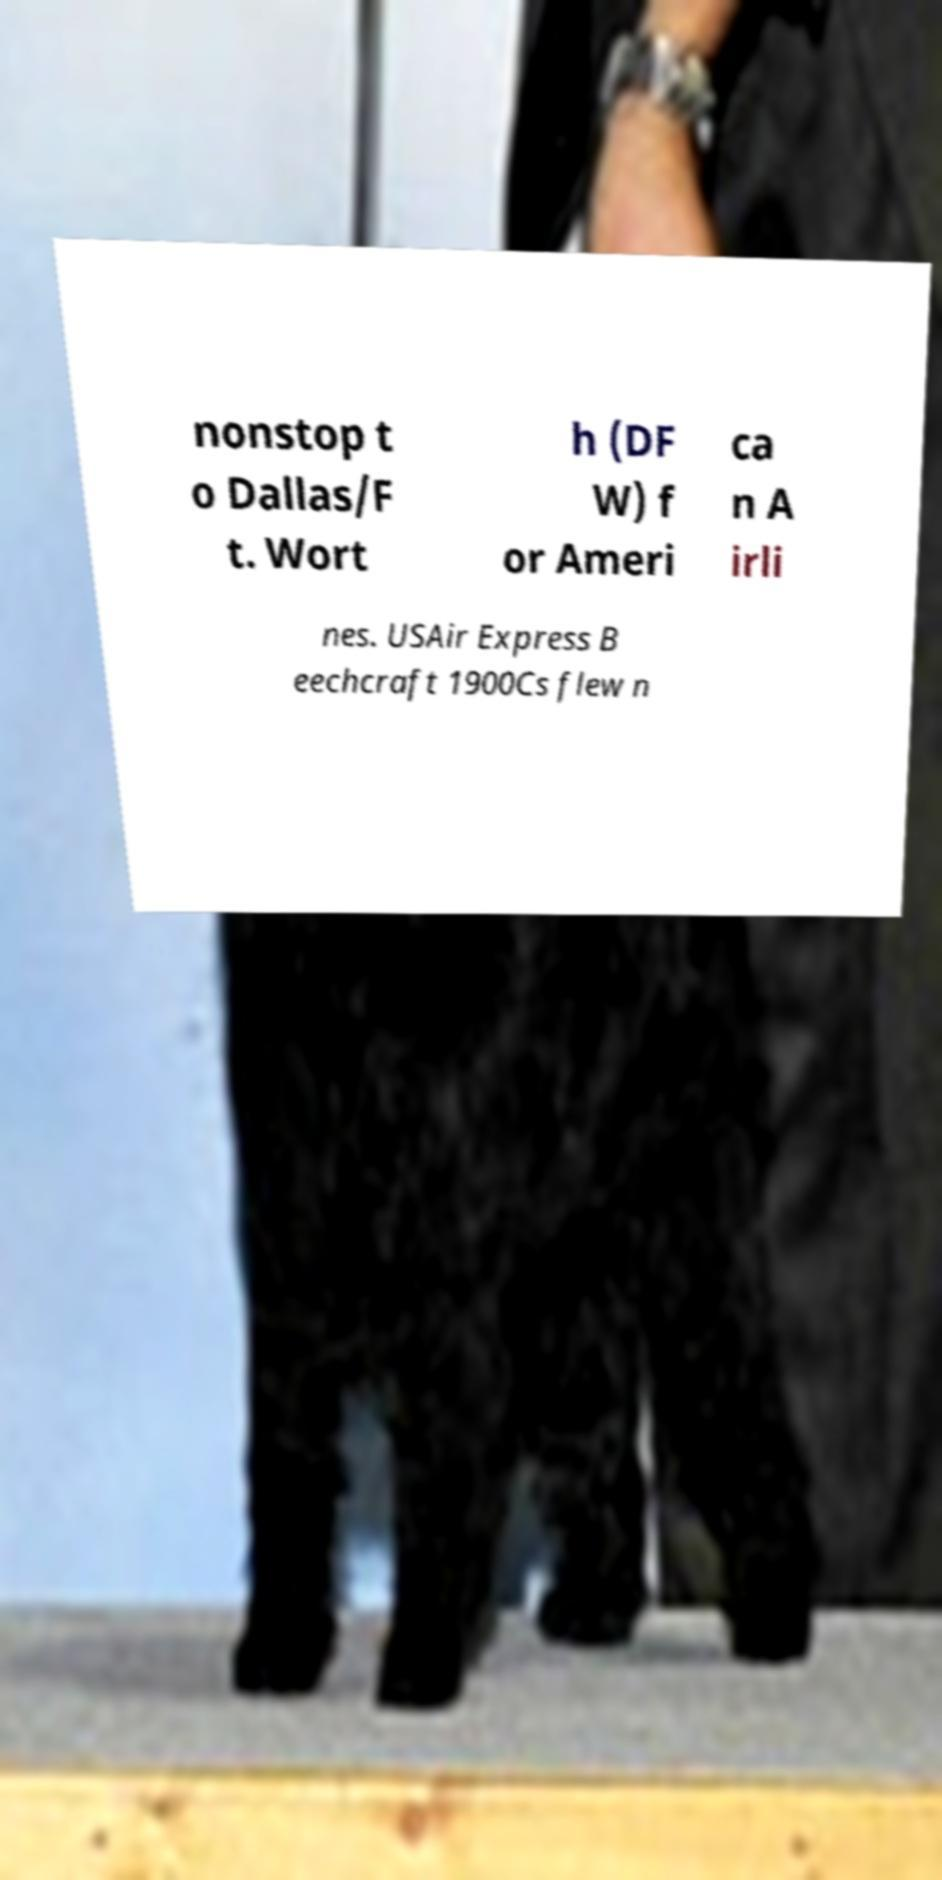Can you accurately transcribe the text from the provided image for me? nonstop t o Dallas/F t. Wort h (DF W) f or Ameri ca n A irli nes. USAir Express B eechcraft 1900Cs flew n 